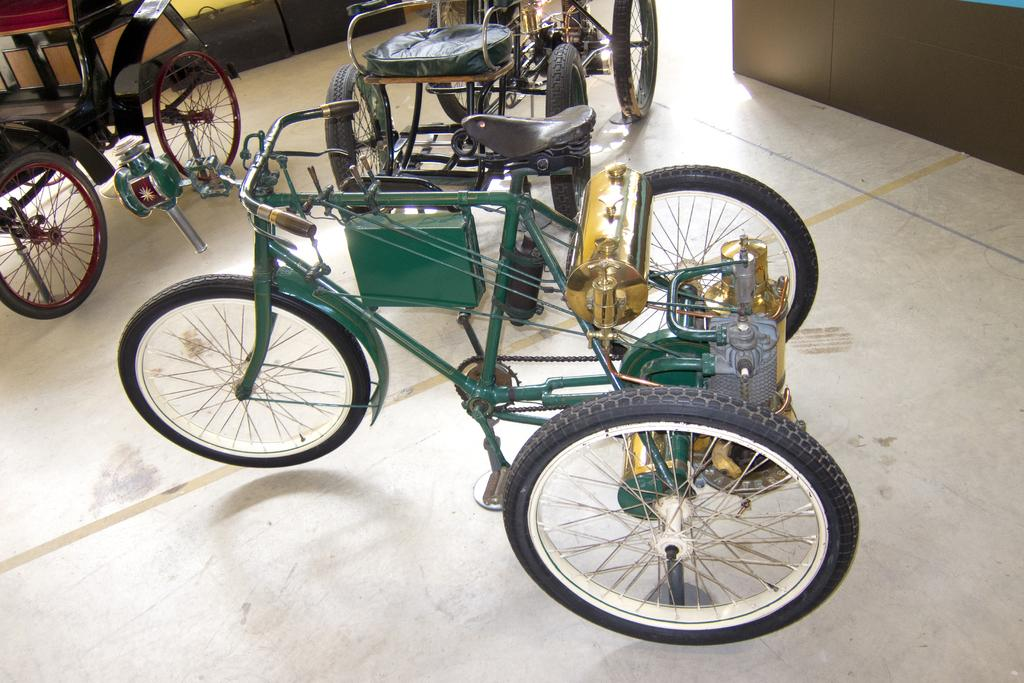What objects are on the floor in the image? There are vehicles on the floor in the image. What can be seen in the top right corner of the image? There is a wall visible in the top right corner of the image. What type of drink is being served in the cart in the image? There is no cart or drink present in the image; it only features vehicles on the floor and a wall in the top right corner. 